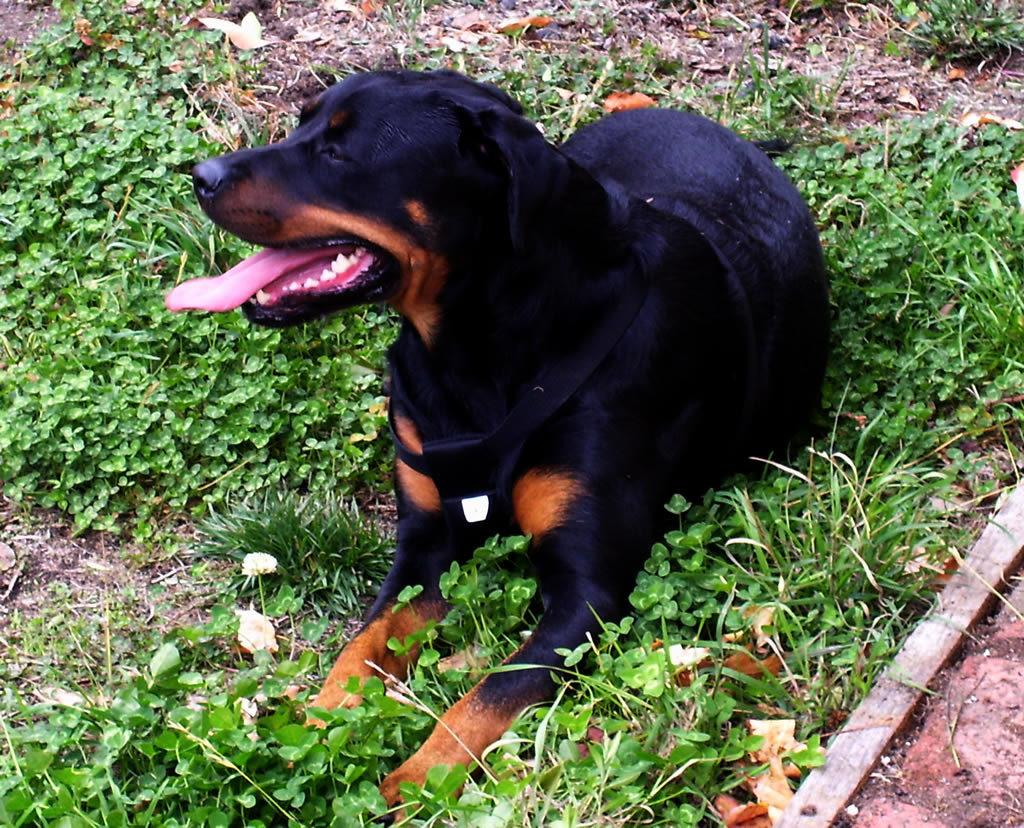What type of animal is in the image? There is a dog in the image. Where is the dog located in the image? The dog is on the ground. What type of vegetation is present in the image? There are plants in the image. What object can be seen on the ground in the image? There is a wooden stick on the ground in the image. What type of quilt is being used to care for the dog in the image? There is no quilt present in the image, and the dog is not being cared for in any way. How many fingers can be seen interacting with the dog in the image? There are no fingers visible in the image, as it only features a dog, plants, and a wooden stick. 